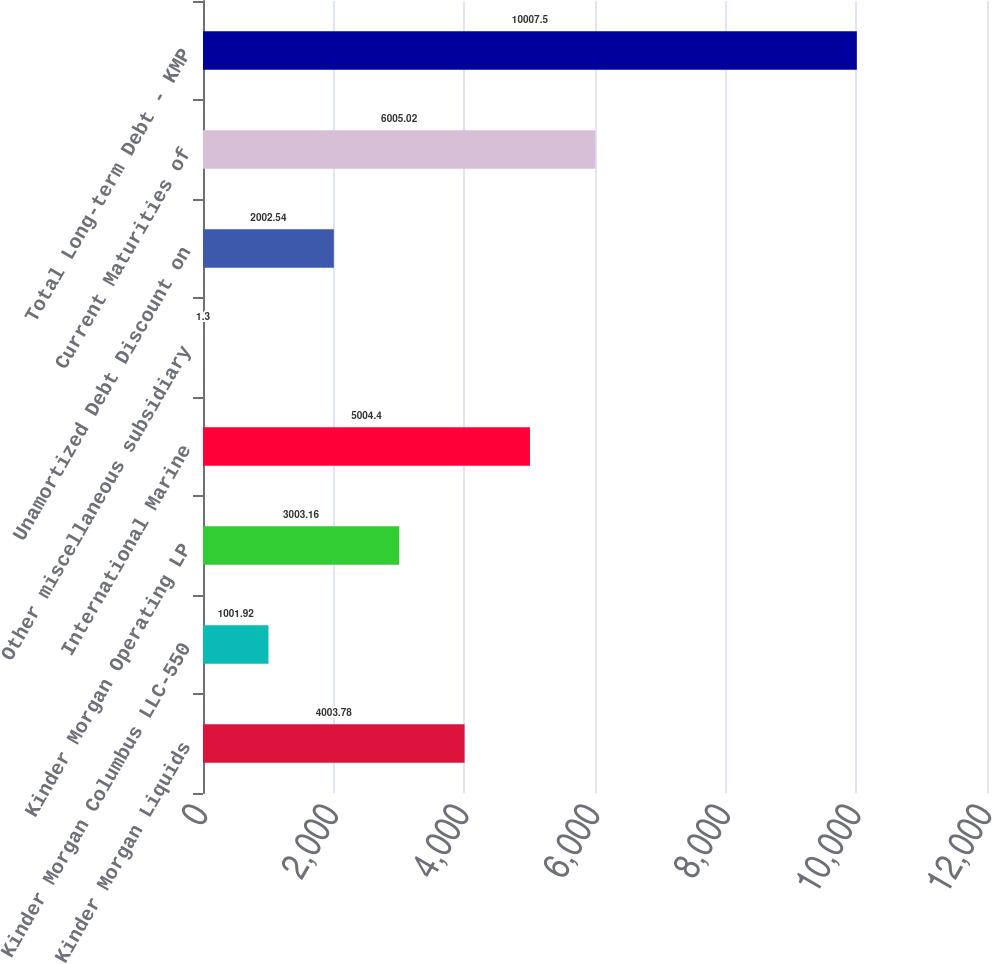Convert chart. <chart><loc_0><loc_0><loc_500><loc_500><bar_chart><fcel>Kinder Morgan Liquids<fcel>Kinder Morgan Columbus LLC-550<fcel>Kinder Morgan Operating LP<fcel>International Marine<fcel>Other miscellaneous subsidiary<fcel>Unamortized Debt Discount on<fcel>Current Maturities of<fcel>Total Long-term Debt - KMP<nl><fcel>4003.78<fcel>1001.92<fcel>3003.16<fcel>5004.4<fcel>1.3<fcel>2002.54<fcel>6005.02<fcel>10007.5<nl></chart> 